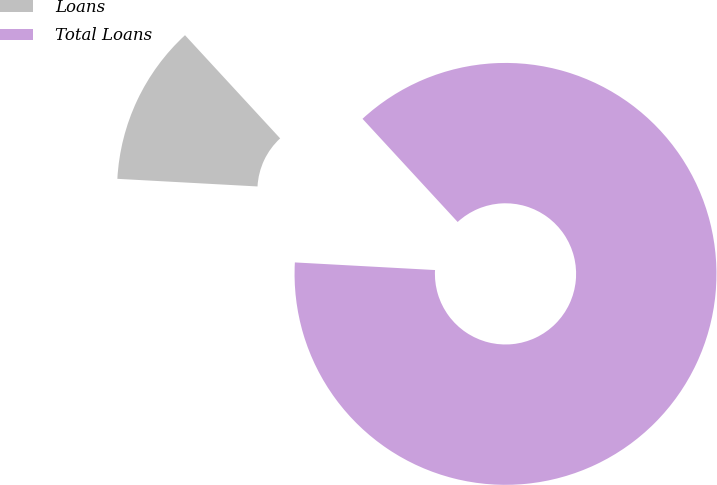Convert chart to OTSL. <chart><loc_0><loc_0><loc_500><loc_500><pie_chart><fcel>Loans<fcel>Total Loans<nl><fcel>12.28%<fcel>87.72%<nl></chart> 